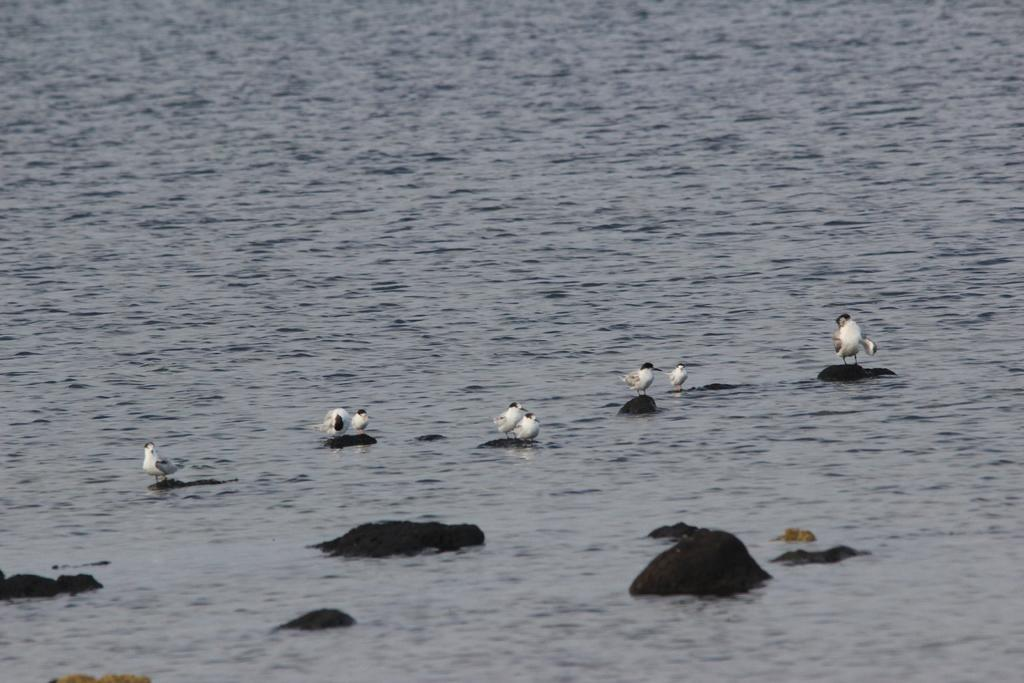What type of animals can be seen in the image? Birds can be seen in the image. What is the primary element in which the birds are situated? The birds are situated on objects on the water in the image. What type of cord can be seen connecting the birds in the image? There is no cord connecting the birds in the image; they are simply situated on objects on the water. 